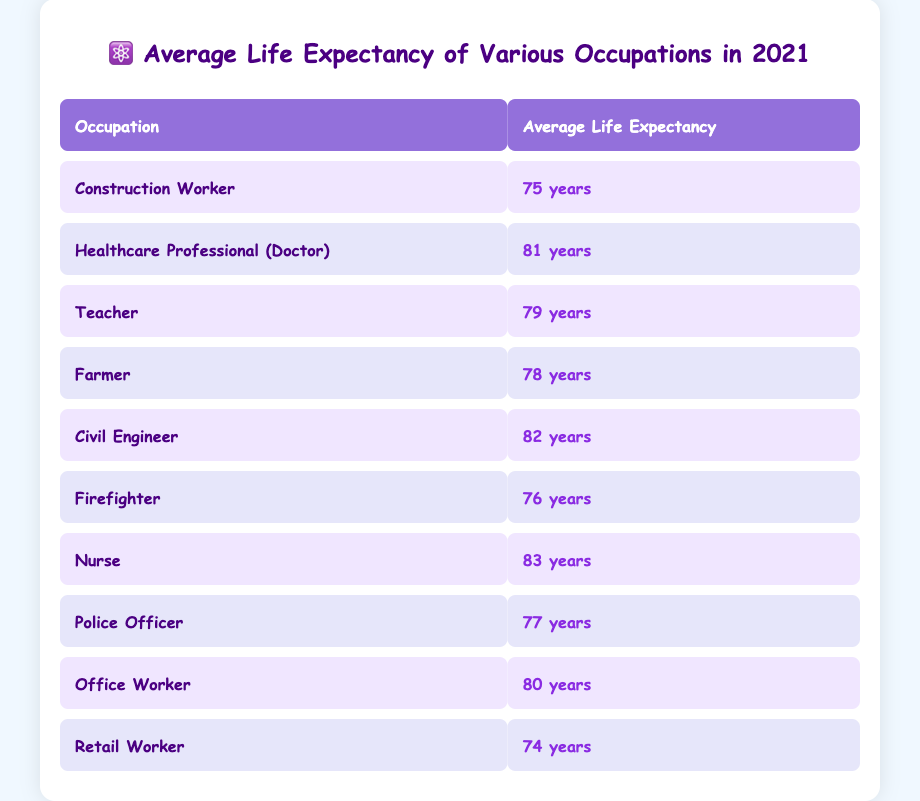What is the average life expectancy of a nurse? The table shows that the average life expectancy for a nurse is listed directly under the "Average Life Expectancy" column for their occupation. The corresponding value for "Nurse" is 83 years.
Answer: 83 years Which occupation has the highest average life expectancy? By scanning through the "Average Life Expectancy" column for all occupations, it is found that the highest value is 83 years, which corresponds to the occupation of "Nurse."
Answer: Nurse Is the average life expectancy of a firefighter greater than 75 years? The average life expectancy for a firefighter is 76 years, which is indeed greater than 75. Therefore, the statement is true.
Answer: Yes How much longer does a civil engineer live on average than a retail worker? The average life expectancy for a civil engineer is 82 years and for a retail worker it is 74 years. The difference is calculated as 82 - 74, which results in 8 years.
Answer: 8 years What is the average life expectancy of all the occupations listed in the table? To find the average life expectancy, sum up the average life expectancy values for all occupations (75 + 81 + 79 + 78 + 82 + 76 + 83 + 77 + 80 + 74 = 790) and divide by the number of occupations (10). Thus, the average life expectancy is 790 / 10 = 79 years.
Answer: 79 years Do healthcare professionals have a longer average life expectancy than teachers? The average life expectancy for healthcare professionals (81 years) is compared to that of teachers (79 years). Since 81 is greater than 79, the statement is true.
Answer: Yes Which occupations have an average life expectancy below 78 years? By reviewing the table, the occupations with life expectancies below 78 years are "Construction Worker" (75), "Firefighter" (76), and "Retail Worker" (74).
Answer: Construction Worker, Firefighter, Retail Worker How does the average life expectancy of an office worker compare to that of a police officer? The average life expectancy for an office worker is 80 years, while for a police officer it is 77 years. Since 80 is greater than 77, an office worker typically lives longer than a police officer.
Answer: Office worker lives longer Is it true that farmers have a higher average life expectancy than construction workers? The average life expectancy for farmers is 78 years and for construction workers it is 75 years. Since 78 is greater than 75, the statement is true.
Answer: Yes 